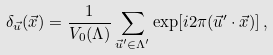<formula> <loc_0><loc_0><loc_500><loc_500>\delta _ { \vec { u } } ( \vec { x } ) = \frac { 1 } { V _ { 0 } ( \Lambda ) } \sum _ { \vec { u } ^ { \prime } \in \Lambda ^ { \prime } } \exp [ i 2 \pi ( \vec { u } ^ { \prime } \cdot \vec { x } ) ] \, ,</formula> 